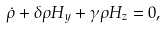<formula> <loc_0><loc_0><loc_500><loc_500>\dot { \rho } + \delta \rho H _ { y } + \gamma \rho H _ { z } = 0 ,</formula> 